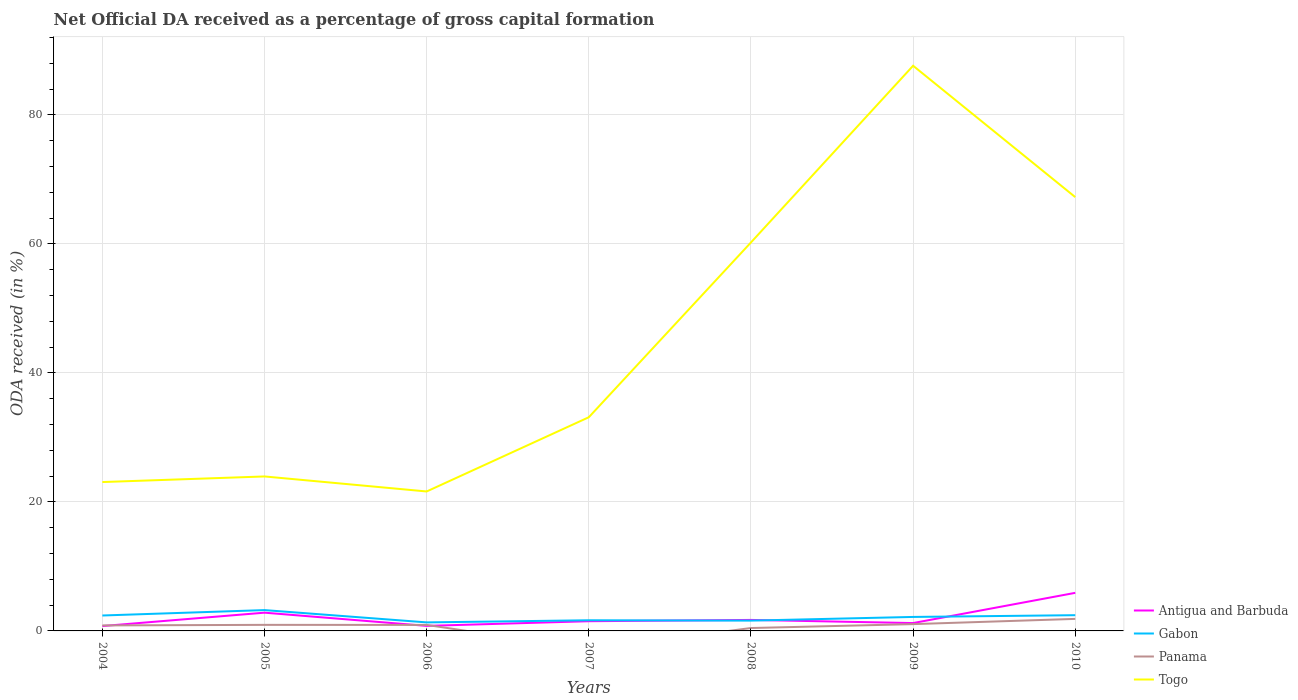Is the number of lines equal to the number of legend labels?
Keep it short and to the point. No. Across all years, what is the maximum net ODA received in Togo?
Provide a succinct answer. 21.62. What is the total net ODA received in Panama in the graph?
Give a very brief answer. -1.01. What is the difference between the highest and the second highest net ODA received in Gabon?
Make the answer very short. 1.91. What is the difference between the highest and the lowest net ODA received in Gabon?
Give a very brief answer. 4. Is the net ODA received in Gabon strictly greater than the net ODA received in Antigua and Barbuda over the years?
Provide a short and direct response. No. How many lines are there?
Make the answer very short. 4. How many years are there in the graph?
Your answer should be compact. 7. Does the graph contain any zero values?
Offer a very short reply. Yes. Does the graph contain grids?
Keep it short and to the point. Yes. Where does the legend appear in the graph?
Your answer should be compact. Bottom right. How are the legend labels stacked?
Offer a terse response. Vertical. What is the title of the graph?
Keep it short and to the point. Net Official DA received as a percentage of gross capital formation. Does "Greece" appear as one of the legend labels in the graph?
Your answer should be compact. No. What is the label or title of the Y-axis?
Your answer should be very brief. ODA received (in %). What is the ODA received (in %) in Antigua and Barbuda in 2004?
Ensure brevity in your answer.  0.75. What is the ODA received (in %) in Gabon in 2004?
Offer a very short reply. 2.39. What is the ODA received (in %) in Panama in 2004?
Provide a short and direct response. 0.85. What is the ODA received (in %) of Togo in 2004?
Your answer should be very brief. 23.08. What is the ODA received (in %) of Antigua and Barbuda in 2005?
Offer a terse response. 2.83. What is the ODA received (in %) of Gabon in 2005?
Provide a short and direct response. 3.23. What is the ODA received (in %) of Panama in 2005?
Keep it short and to the point. 0.94. What is the ODA received (in %) of Togo in 2005?
Give a very brief answer. 23.95. What is the ODA received (in %) of Antigua and Barbuda in 2006?
Keep it short and to the point. 0.78. What is the ODA received (in %) in Gabon in 2006?
Ensure brevity in your answer.  1.32. What is the ODA received (in %) in Panama in 2006?
Provide a short and direct response. 0.93. What is the ODA received (in %) of Togo in 2006?
Provide a short and direct response. 21.62. What is the ODA received (in %) of Antigua and Barbuda in 2007?
Provide a short and direct response. 1.51. What is the ODA received (in %) of Gabon in 2007?
Your response must be concise. 1.65. What is the ODA received (in %) of Togo in 2007?
Offer a very short reply. 33.13. What is the ODA received (in %) in Antigua and Barbuda in 2008?
Ensure brevity in your answer.  1.71. What is the ODA received (in %) of Gabon in 2008?
Give a very brief answer. 1.6. What is the ODA received (in %) in Panama in 2008?
Keep it short and to the point. 0.45. What is the ODA received (in %) of Togo in 2008?
Keep it short and to the point. 60.24. What is the ODA received (in %) in Antigua and Barbuda in 2009?
Provide a short and direct response. 1.22. What is the ODA received (in %) in Gabon in 2009?
Make the answer very short. 2.17. What is the ODA received (in %) in Panama in 2009?
Offer a terse response. 1.05. What is the ODA received (in %) of Togo in 2009?
Your answer should be compact. 87.63. What is the ODA received (in %) of Antigua and Barbuda in 2010?
Make the answer very short. 5.9. What is the ODA received (in %) of Gabon in 2010?
Provide a succinct answer. 2.44. What is the ODA received (in %) of Panama in 2010?
Your answer should be compact. 1.87. What is the ODA received (in %) in Togo in 2010?
Your answer should be compact. 67.27. Across all years, what is the maximum ODA received (in %) of Antigua and Barbuda?
Your response must be concise. 5.9. Across all years, what is the maximum ODA received (in %) of Gabon?
Keep it short and to the point. 3.23. Across all years, what is the maximum ODA received (in %) of Panama?
Your answer should be very brief. 1.87. Across all years, what is the maximum ODA received (in %) in Togo?
Your response must be concise. 87.63. Across all years, what is the minimum ODA received (in %) of Antigua and Barbuda?
Give a very brief answer. 0.75. Across all years, what is the minimum ODA received (in %) in Gabon?
Provide a succinct answer. 1.32. Across all years, what is the minimum ODA received (in %) of Togo?
Offer a very short reply. 21.62. What is the total ODA received (in %) in Antigua and Barbuda in the graph?
Give a very brief answer. 14.7. What is the total ODA received (in %) of Gabon in the graph?
Provide a succinct answer. 14.8. What is the total ODA received (in %) in Panama in the graph?
Ensure brevity in your answer.  6.09. What is the total ODA received (in %) in Togo in the graph?
Provide a short and direct response. 316.93. What is the difference between the ODA received (in %) in Antigua and Barbuda in 2004 and that in 2005?
Ensure brevity in your answer.  -2.08. What is the difference between the ODA received (in %) of Gabon in 2004 and that in 2005?
Your response must be concise. -0.84. What is the difference between the ODA received (in %) in Panama in 2004 and that in 2005?
Keep it short and to the point. -0.09. What is the difference between the ODA received (in %) in Togo in 2004 and that in 2005?
Your response must be concise. -0.87. What is the difference between the ODA received (in %) of Antigua and Barbuda in 2004 and that in 2006?
Your response must be concise. -0.03. What is the difference between the ODA received (in %) in Gabon in 2004 and that in 2006?
Provide a succinct answer. 1.07. What is the difference between the ODA received (in %) of Panama in 2004 and that in 2006?
Make the answer very short. -0.08. What is the difference between the ODA received (in %) in Togo in 2004 and that in 2006?
Give a very brief answer. 1.46. What is the difference between the ODA received (in %) of Antigua and Barbuda in 2004 and that in 2007?
Offer a terse response. -0.75. What is the difference between the ODA received (in %) in Gabon in 2004 and that in 2007?
Give a very brief answer. 0.74. What is the difference between the ODA received (in %) in Togo in 2004 and that in 2007?
Your answer should be compact. -10.05. What is the difference between the ODA received (in %) of Antigua and Barbuda in 2004 and that in 2008?
Offer a very short reply. -0.95. What is the difference between the ODA received (in %) in Gabon in 2004 and that in 2008?
Ensure brevity in your answer.  0.79. What is the difference between the ODA received (in %) in Panama in 2004 and that in 2008?
Your response must be concise. 0.4. What is the difference between the ODA received (in %) of Togo in 2004 and that in 2008?
Provide a succinct answer. -37.15. What is the difference between the ODA received (in %) of Antigua and Barbuda in 2004 and that in 2009?
Your response must be concise. -0.46. What is the difference between the ODA received (in %) of Gabon in 2004 and that in 2009?
Make the answer very short. 0.22. What is the difference between the ODA received (in %) of Panama in 2004 and that in 2009?
Offer a very short reply. -0.2. What is the difference between the ODA received (in %) of Togo in 2004 and that in 2009?
Make the answer very short. -64.55. What is the difference between the ODA received (in %) in Antigua and Barbuda in 2004 and that in 2010?
Your response must be concise. -5.15. What is the difference between the ODA received (in %) of Gabon in 2004 and that in 2010?
Offer a very short reply. -0.05. What is the difference between the ODA received (in %) in Panama in 2004 and that in 2010?
Offer a terse response. -1.01. What is the difference between the ODA received (in %) in Togo in 2004 and that in 2010?
Your response must be concise. -44.18. What is the difference between the ODA received (in %) of Antigua and Barbuda in 2005 and that in 2006?
Provide a succinct answer. 2.05. What is the difference between the ODA received (in %) of Gabon in 2005 and that in 2006?
Your response must be concise. 1.91. What is the difference between the ODA received (in %) in Panama in 2005 and that in 2006?
Provide a succinct answer. 0.01. What is the difference between the ODA received (in %) of Togo in 2005 and that in 2006?
Provide a short and direct response. 2.33. What is the difference between the ODA received (in %) in Antigua and Barbuda in 2005 and that in 2007?
Your answer should be compact. 1.32. What is the difference between the ODA received (in %) of Gabon in 2005 and that in 2007?
Your answer should be compact. 1.58. What is the difference between the ODA received (in %) in Togo in 2005 and that in 2007?
Offer a very short reply. -9.18. What is the difference between the ODA received (in %) of Antigua and Barbuda in 2005 and that in 2008?
Give a very brief answer. 1.12. What is the difference between the ODA received (in %) of Gabon in 2005 and that in 2008?
Keep it short and to the point. 1.63. What is the difference between the ODA received (in %) of Panama in 2005 and that in 2008?
Provide a short and direct response. 0.49. What is the difference between the ODA received (in %) of Togo in 2005 and that in 2008?
Your response must be concise. -36.29. What is the difference between the ODA received (in %) in Antigua and Barbuda in 2005 and that in 2009?
Ensure brevity in your answer.  1.61. What is the difference between the ODA received (in %) of Gabon in 2005 and that in 2009?
Give a very brief answer. 1.06. What is the difference between the ODA received (in %) in Panama in 2005 and that in 2009?
Your answer should be very brief. -0.11. What is the difference between the ODA received (in %) of Togo in 2005 and that in 2009?
Offer a very short reply. -63.68. What is the difference between the ODA received (in %) of Antigua and Barbuda in 2005 and that in 2010?
Provide a succinct answer. -3.07. What is the difference between the ODA received (in %) in Gabon in 2005 and that in 2010?
Make the answer very short. 0.79. What is the difference between the ODA received (in %) of Panama in 2005 and that in 2010?
Provide a succinct answer. -0.93. What is the difference between the ODA received (in %) in Togo in 2005 and that in 2010?
Make the answer very short. -43.31. What is the difference between the ODA received (in %) of Antigua and Barbuda in 2006 and that in 2007?
Your answer should be very brief. -0.72. What is the difference between the ODA received (in %) of Gabon in 2006 and that in 2007?
Ensure brevity in your answer.  -0.33. What is the difference between the ODA received (in %) of Togo in 2006 and that in 2007?
Make the answer very short. -11.51. What is the difference between the ODA received (in %) of Antigua and Barbuda in 2006 and that in 2008?
Offer a very short reply. -0.92. What is the difference between the ODA received (in %) in Gabon in 2006 and that in 2008?
Ensure brevity in your answer.  -0.28. What is the difference between the ODA received (in %) of Panama in 2006 and that in 2008?
Provide a short and direct response. 0.48. What is the difference between the ODA received (in %) in Togo in 2006 and that in 2008?
Give a very brief answer. -38.61. What is the difference between the ODA received (in %) in Antigua and Barbuda in 2006 and that in 2009?
Your answer should be very brief. -0.44. What is the difference between the ODA received (in %) in Gabon in 2006 and that in 2009?
Make the answer very short. -0.85. What is the difference between the ODA received (in %) in Panama in 2006 and that in 2009?
Your answer should be compact. -0.12. What is the difference between the ODA received (in %) of Togo in 2006 and that in 2009?
Make the answer very short. -66.01. What is the difference between the ODA received (in %) of Antigua and Barbuda in 2006 and that in 2010?
Provide a succinct answer. -5.12. What is the difference between the ODA received (in %) in Gabon in 2006 and that in 2010?
Provide a short and direct response. -1.12. What is the difference between the ODA received (in %) of Panama in 2006 and that in 2010?
Offer a terse response. -0.94. What is the difference between the ODA received (in %) in Togo in 2006 and that in 2010?
Provide a short and direct response. -45.64. What is the difference between the ODA received (in %) in Antigua and Barbuda in 2007 and that in 2008?
Your answer should be compact. -0.2. What is the difference between the ODA received (in %) in Gabon in 2007 and that in 2008?
Provide a short and direct response. 0.05. What is the difference between the ODA received (in %) in Togo in 2007 and that in 2008?
Give a very brief answer. -27.11. What is the difference between the ODA received (in %) of Antigua and Barbuda in 2007 and that in 2009?
Your response must be concise. 0.29. What is the difference between the ODA received (in %) in Gabon in 2007 and that in 2009?
Your response must be concise. -0.51. What is the difference between the ODA received (in %) in Togo in 2007 and that in 2009?
Keep it short and to the point. -54.5. What is the difference between the ODA received (in %) in Antigua and Barbuda in 2007 and that in 2010?
Provide a succinct answer. -4.4. What is the difference between the ODA received (in %) of Gabon in 2007 and that in 2010?
Keep it short and to the point. -0.79. What is the difference between the ODA received (in %) in Togo in 2007 and that in 2010?
Keep it short and to the point. -34.13. What is the difference between the ODA received (in %) in Antigua and Barbuda in 2008 and that in 2009?
Provide a short and direct response. 0.49. What is the difference between the ODA received (in %) of Gabon in 2008 and that in 2009?
Keep it short and to the point. -0.57. What is the difference between the ODA received (in %) of Panama in 2008 and that in 2009?
Offer a very short reply. -0.6. What is the difference between the ODA received (in %) of Togo in 2008 and that in 2009?
Give a very brief answer. -27.4. What is the difference between the ODA received (in %) in Antigua and Barbuda in 2008 and that in 2010?
Provide a succinct answer. -4.2. What is the difference between the ODA received (in %) of Gabon in 2008 and that in 2010?
Ensure brevity in your answer.  -0.84. What is the difference between the ODA received (in %) of Panama in 2008 and that in 2010?
Your response must be concise. -1.42. What is the difference between the ODA received (in %) of Togo in 2008 and that in 2010?
Make the answer very short. -7.03. What is the difference between the ODA received (in %) of Antigua and Barbuda in 2009 and that in 2010?
Keep it short and to the point. -4.69. What is the difference between the ODA received (in %) of Gabon in 2009 and that in 2010?
Ensure brevity in your answer.  -0.27. What is the difference between the ODA received (in %) of Panama in 2009 and that in 2010?
Provide a succinct answer. -0.81. What is the difference between the ODA received (in %) of Togo in 2009 and that in 2010?
Provide a short and direct response. 20.37. What is the difference between the ODA received (in %) in Antigua and Barbuda in 2004 and the ODA received (in %) in Gabon in 2005?
Offer a terse response. -2.48. What is the difference between the ODA received (in %) of Antigua and Barbuda in 2004 and the ODA received (in %) of Panama in 2005?
Make the answer very short. -0.19. What is the difference between the ODA received (in %) of Antigua and Barbuda in 2004 and the ODA received (in %) of Togo in 2005?
Make the answer very short. -23.2. What is the difference between the ODA received (in %) in Gabon in 2004 and the ODA received (in %) in Panama in 2005?
Your answer should be very brief. 1.45. What is the difference between the ODA received (in %) in Gabon in 2004 and the ODA received (in %) in Togo in 2005?
Ensure brevity in your answer.  -21.56. What is the difference between the ODA received (in %) of Panama in 2004 and the ODA received (in %) of Togo in 2005?
Make the answer very short. -23.1. What is the difference between the ODA received (in %) in Antigua and Barbuda in 2004 and the ODA received (in %) in Gabon in 2006?
Ensure brevity in your answer.  -0.57. What is the difference between the ODA received (in %) in Antigua and Barbuda in 2004 and the ODA received (in %) in Panama in 2006?
Give a very brief answer. -0.18. What is the difference between the ODA received (in %) of Antigua and Barbuda in 2004 and the ODA received (in %) of Togo in 2006?
Offer a terse response. -20.87. What is the difference between the ODA received (in %) in Gabon in 2004 and the ODA received (in %) in Panama in 2006?
Offer a very short reply. 1.46. What is the difference between the ODA received (in %) in Gabon in 2004 and the ODA received (in %) in Togo in 2006?
Provide a short and direct response. -19.23. What is the difference between the ODA received (in %) of Panama in 2004 and the ODA received (in %) of Togo in 2006?
Your answer should be very brief. -20.77. What is the difference between the ODA received (in %) of Antigua and Barbuda in 2004 and the ODA received (in %) of Gabon in 2007?
Your answer should be compact. -0.9. What is the difference between the ODA received (in %) of Antigua and Barbuda in 2004 and the ODA received (in %) of Togo in 2007?
Your answer should be very brief. -32.38. What is the difference between the ODA received (in %) of Gabon in 2004 and the ODA received (in %) of Togo in 2007?
Provide a short and direct response. -30.74. What is the difference between the ODA received (in %) in Panama in 2004 and the ODA received (in %) in Togo in 2007?
Provide a succinct answer. -32.28. What is the difference between the ODA received (in %) of Antigua and Barbuda in 2004 and the ODA received (in %) of Gabon in 2008?
Ensure brevity in your answer.  -0.84. What is the difference between the ODA received (in %) of Antigua and Barbuda in 2004 and the ODA received (in %) of Panama in 2008?
Provide a short and direct response. 0.3. What is the difference between the ODA received (in %) of Antigua and Barbuda in 2004 and the ODA received (in %) of Togo in 2008?
Offer a terse response. -59.48. What is the difference between the ODA received (in %) of Gabon in 2004 and the ODA received (in %) of Panama in 2008?
Offer a terse response. 1.94. What is the difference between the ODA received (in %) in Gabon in 2004 and the ODA received (in %) in Togo in 2008?
Give a very brief answer. -57.85. What is the difference between the ODA received (in %) in Panama in 2004 and the ODA received (in %) in Togo in 2008?
Your response must be concise. -59.39. What is the difference between the ODA received (in %) in Antigua and Barbuda in 2004 and the ODA received (in %) in Gabon in 2009?
Provide a succinct answer. -1.41. What is the difference between the ODA received (in %) of Antigua and Barbuda in 2004 and the ODA received (in %) of Panama in 2009?
Keep it short and to the point. -0.3. What is the difference between the ODA received (in %) in Antigua and Barbuda in 2004 and the ODA received (in %) in Togo in 2009?
Your response must be concise. -86.88. What is the difference between the ODA received (in %) in Gabon in 2004 and the ODA received (in %) in Panama in 2009?
Provide a short and direct response. 1.34. What is the difference between the ODA received (in %) in Gabon in 2004 and the ODA received (in %) in Togo in 2009?
Your answer should be very brief. -85.24. What is the difference between the ODA received (in %) in Panama in 2004 and the ODA received (in %) in Togo in 2009?
Make the answer very short. -86.78. What is the difference between the ODA received (in %) in Antigua and Barbuda in 2004 and the ODA received (in %) in Gabon in 2010?
Give a very brief answer. -1.68. What is the difference between the ODA received (in %) in Antigua and Barbuda in 2004 and the ODA received (in %) in Panama in 2010?
Provide a succinct answer. -1.11. What is the difference between the ODA received (in %) of Antigua and Barbuda in 2004 and the ODA received (in %) of Togo in 2010?
Your answer should be very brief. -66.51. What is the difference between the ODA received (in %) in Gabon in 2004 and the ODA received (in %) in Panama in 2010?
Your response must be concise. 0.53. What is the difference between the ODA received (in %) in Gabon in 2004 and the ODA received (in %) in Togo in 2010?
Your answer should be compact. -64.87. What is the difference between the ODA received (in %) in Panama in 2004 and the ODA received (in %) in Togo in 2010?
Give a very brief answer. -66.41. What is the difference between the ODA received (in %) in Antigua and Barbuda in 2005 and the ODA received (in %) in Gabon in 2006?
Give a very brief answer. 1.51. What is the difference between the ODA received (in %) of Antigua and Barbuda in 2005 and the ODA received (in %) of Panama in 2006?
Offer a very short reply. 1.9. What is the difference between the ODA received (in %) of Antigua and Barbuda in 2005 and the ODA received (in %) of Togo in 2006?
Give a very brief answer. -18.79. What is the difference between the ODA received (in %) of Gabon in 2005 and the ODA received (in %) of Panama in 2006?
Your response must be concise. 2.3. What is the difference between the ODA received (in %) in Gabon in 2005 and the ODA received (in %) in Togo in 2006?
Provide a short and direct response. -18.39. What is the difference between the ODA received (in %) in Panama in 2005 and the ODA received (in %) in Togo in 2006?
Your answer should be very brief. -20.68. What is the difference between the ODA received (in %) of Antigua and Barbuda in 2005 and the ODA received (in %) of Gabon in 2007?
Provide a short and direct response. 1.18. What is the difference between the ODA received (in %) of Antigua and Barbuda in 2005 and the ODA received (in %) of Togo in 2007?
Your response must be concise. -30.3. What is the difference between the ODA received (in %) of Gabon in 2005 and the ODA received (in %) of Togo in 2007?
Your response must be concise. -29.9. What is the difference between the ODA received (in %) of Panama in 2005 and the ODA received (in %) of Togo in 2007?
Give a very brief answer. -32.19. What is the difference between the ODA received (in %) of Antigua and Barbuda in 2005 and the ODA received (in %) of Gabon in 2008?
Give a very brief answer. 1.23. What is the difference between the ODA received (in %) of Antigua and Barbuda in 2005 and the ODA received (in %) of Panama in 2008?
Offer a very short reply. 2.38. What is the difference between the ODA received (in %) in Antigua and Barbuda in 2005 and the ODA received (in %) in Togo in 2008?
Provide a succinct answer. -57.41. What is the difference between the ODA received (in %) of Gabon in 2005 and the ODA received (in %) of Panama in 2008?
Keep it short and to the point. 2.78. What is the difference between the ODA received (in %) in Gabon in 2005 and the ODA received (in %) in Togo in 2008?
Your answer should be very brief. -57.01. What is the difference between the ODA received (in %) of Panama in 2005 and the ODA received (in %) of Togo in 2008?
Keep it short and to the point. -59.3. What is the difference between the ODA received (in %) in Antigua and Barbuda in 2005 and the ODA received (in %) in Gabon in 2009?
Give a very brief answer. 0.66. What is the difference between the ODA received (in %) of Antigua and Barbuda in 2005 and the ODA received (in %) of Panama in 2009?
Give a very brief answer. 1.78. What is the difference between the ODA received (in %) in Antigua and Barbuda in 2005 and the ODA received (in %) in Togo in 2009?
Your answer should be very brief. -84.8. What is the difference between the ODA received (in %) in Gabon in 2005 and the ODA received (in %) in Panama in 2009?
Give a very brief answer. 2.18. What is the difference between the ODA received (in %) of Gabon in 2005 and the ODA received (in %) of Togo in 2009?
Ensure brevity in your answer.  -84.41. What is the difference between the ODA received (in %) in Panama in 2005 and the ODA received (in %) in Togo in 2009?
Your answer should be very brief. -86.69. What is the difference between the ODA received (in %) of Antigua and Barbuda in 2005 and the ODA received (in %) of Gabon in 2010?
Provide a short and direct response. 0.39. What is the difference between the ODA received (in %) of Antigua and Barbuda in 2005 and the ODA received (in %) of Panama in 2010?
Make the answer very short. 0.96. What is the difference between the ODA received (in %) of Antigua and Barbuda in 2005 and the ODA received (in %) of Togo in 2010?
Give a very brief answer. -64.44. What is the difference between the ODA received (in %) of Gabon in 2005 and the ODA received (in %) of Panama in 2010?
Make the answer very short. 1.36. What is the difference between the ODA received (in %) in Gabon in 2005 and the ODA received (in %) in Togo in 2010?
Your answer should be compact. -64.04. What is the difference between the ODA received (in %) in Panama in 2005 and the ODA received (in %) in Togo in 2010?
Offer a terse response. -66.33. What is the difference between the ODA received (in %) in Antigua and Barbuda in 2006 and the ODA received (in %) in Gabon in 2007?
Give a very brief answer. -0.87. What is the difference between the ODA received (in %) in Antigua and Barbuda in 2006 and the ODA received (in %) in Togo in 2007?
Provide a short and direct response. -32.35. What is the difference between the ODA received (in %) in Gabon in 2006 and the ODA received (in %) in Togo in 2007?
Offer a terse response. -31.81. What is the difference between the ODA received (in %) of Panama in 2006 and the ODA received (in %) of Togo in 2007?
Keep it short and to the point. -32.2. What is the difference between the ODA received (in %) of Antigua and Barbuda in 2006 and the ODA received (in %) of Gabon in 2008?
Make the answer very short. -0.82. What is the difference between the ODA received (in %) in Antigua and Barbuda in 2006 and the ODA received (in %) in Panama in 2008?
Give a very brief answer. 0.33. What is the difference between the ODA received (in %) in Antigua and Barbuda in 2006 and the ODA received (in %) in Togo in 2008?
Your answer should be compact. -59.45. What is the difference between the ODA received (in %) in Gabon in 2006 and the ODA received (in %) in Panama in 2008?
Your response must be concise. 0.87. What is the difference between the ODA received (in %) in Gabon in 2006 and the ODA received (in %) in Togo in 2008?
Your answer should be very brief. -58.92. What is the difference between the ODA received (in %) in Panama in 2006 and the ODA received (in %) in Togo in 2008?
Provide a short and direct response. -59.31. What is the difference between the ODA received (in %) in Antigua and Barbuda in 2006 and the ODA received (in %) in Gabon in 2009?
Keep it short and to the point. -1.38. What is the difference between the ODA received (in %) of Antigua and Barbuda in 2006 and the ODA received (in %) of Panama in 2009?
Offer a very short reply. -0.27. What is the difference between the ODA received (in %) in Antigua and Barbuda in 2006 and the ODA received (in %) in Togo in 2009?
Ensure brevity in your answer.  -86.85. What is the difference between the ODA received (in %) in Gabon in 2006 and the ODA received (in %) in Panama in 2009?
Provide a succinct answer. 0.27. What is the difference between the ODA received (in %) of Gabon in 2006 and the ODA received (in %) of Togo in 2009?
Your answer should be very brief. -86.31. What is the difference between the ODA received (in %) in Panama in 2006 and the ODA received (in %) in Togo in 2009?
Your answer should be very brief. -86.7. What is the difference between the ODA received (in %) of Antigua and Barbuda in 2006 and the ODA received (in %) of Gabon in 2010?
Offer a very short reply. -1.66. What is the difference between the ODA received (in %) of Antigua and Barbuda in 2006 and the ODA received (in %) of Panama in 2010?
Make the answer very short. -1.08. What is the difference between the ODA received (in %) in Antigua and Barbuda in 2006 and the ODA received (in %) in Togo in 2010?
Ensure brevity in your answer.  -66.48. What is the difference between the ODA received (in %) in Gabon in 2006 and the ODA received (in %) in Panama in 2010?
Give a very brief answer. -0.54. What is the difference between the ODA received (in %) of Gabon in 2006 and the ODA received (in %) of Togo in 2010?
Keep it short and to the point. -65.94. What is the difference between the ODA received (in %) in Panama in 2006 and the ODA received (in %) in Togo in 2010?
Your answer should be very brief. -66.34. What is the difference between the ODA received (in %) in Antigua and Barbuda in 2007 and the ODA received (in %) in Gabon in 2008?
Your response must be concise. -0.09. What is the difference between the ODA received (in %) of Antigua and Barbuda in 2007 and the ODA received (in %) of Panama in 2008?
Give a very brief answer. 1.06. What is the difference between the ODA received (in %) of Antigua and Barbuda in 2007 and the ODA received (in %) of Togo in 2008?
Make the answer very short. -58.73. What is the difference between the ODA received (in %) in Gabon in 2007 and the ODA received (in %) in Panama in 2008?
Your answer should be very brief. 1.2. What is the difference between the ODA received (in %) of Gabon in 2007 and the ODA received (in %) of Togo in 2008?
Keep it short and to the point. -58.59. What is the difference between the ODA received (in %) in Antigua and Barbuda in 2007 and the ODA received (in %) in Gabon in 2009?
Your response must be concise. -0.66. What is the difference between the ODA received (in %) of Antigua and Barbuda in 2007 and the ODA received (in %) of Panama in 2009?
Your response must be concise. 0.45. What is the difference between the ODA received (in %) of Antigua and Barbuda in 2007 and the ODA received (in %) of Togo in 2009?
Provide a short and direct response. -86.13. What is the difference between the ODA received (in %) of Gabon in 2007 and the ODA received (in %) of Panama in 2009?
Provide a succinct answer. 0.6. What is the difference between the ODA received (in %) of Gabon in 2007 and the ODA received (in %) of Togo in 2009?
Your answer should be compact. -85.98. What is the difference between the ODA received (in %) in Antigua and Barbuda in 2007 and the ODA received (in %) in Gabon in 2010?
Your answer should be compact. -0.93. What is the difference between the ODA received (in %) in Antigua and Barbuda in 2007 and the ODA received (in %) in Panama in 2010?
Give a very brief answer. -0.36. What is the difference between the ODA received (in %) in Antigua and Barbuda in 2007 and the ODA received (in %) in Togo in 2010?
Make the answer very short. -65.76. What is the difference between the ODA received (in %) of Gabon in 2007 and the ODA received (in %) of Panama in 2010?
Your answer should be compact. -0.21. What is the difference between the ODA received (in %) of Gabon in 2007 and the ODA received (in %) of Togo in 2010?
Your answer should be very brief. -65.61. What is the difference between the ODA received (in %) of Antigua and Barbuda in 2008 and the ODA received (in %) of Gabon in 2009?
Your answer should be compact. -0.46. What is the difference between the ODA received (in %) in Antigua and Barbuda in 2008 and the ODA received (in %) in Panama in 2009?
Ensure brevity in your answer.  0.65. What is the difference between the ODA received (in %) of Antigua and Barbuda in 2008 and the ODA received (in %) of Togo in 2009?
Provide a short and direct response. -85.93. What is the difference between the ODA received (in %) in Gabon in 2008 and the ODA received (in %) in Panama in 2009?
Keep it short and to the point. 0.55. What is the difference between the ODA received (in %) in Gabon in 2008 and the ODA received (in %) in Togo in 2009?
Your answer should be compact. -86.04. What is the difference between the ODA received (in %) in Panama in 2008 and the ODA received (in %) in Togo in 2009?
Provide a succinct answer. -87.19. What is the difference between the ODA received (in %) of Antigua and Barbuda in 2008 and the ODA received (in %) of Gabon in 2010?
Offer a terse response. -0.73. What is the difference between the ODA received (in %) of Antigua and Barbuda in 2008 and the ODA received (in %) of Panama in 2010?
Offer a very short reply. -0.16. What is the difference between the ODA received (in %) in Antigua and Barbuda in 2008 and the ODA received (in %) in Togo in 2010?
Provide a short and direct response. -65.56. What is the difference between the ODA received (in %) of Gabon in 2008 and the ODA received (in %) of Panama in 2010?
Your answer should be very brief. -0.27. What is the difference between the ODA received (in %) in Gabon in 2008 and the ODA received (in %) in Togo in 2010?
Offer a terse response. -65.67. What is the difference between the ODA received (in %) in Panama in 2008 and the ODA received (in %) in Togo in 2010?
Your answer should be compact. -66.82. What is the difference between the ODA received (in %) of Antigua and Barbuda in 2009 and the ODA received (in %) of Gabon in 2010?
Offer a terse response. -1.22. What is the difference between the ODA received (in %) of Antigua and Barbuda in 2009 and the ODA received (in %) of Panama in 2010?
Offer a very short reply. -0.65. What is the difference between the ODA received (in %) in Antigua and Barbuda in 2009 and the ODA received (in %) in Togo in 2010?
Offer a very short reply. -66.05. What is the difference between the ODA received (in %) in Gabon in 2009 and the ODA received (in %) in Panama in 2010?
Keep it short and to the point. 0.3. What is the difference between the ODA received (in %) in Gabon in 2009 and the ODA received (in %) in Togo in 2010?
Your answer should be very brief. -65.1. What is the difference between the ODA received (in %) of Panama in 2009 and the ODA received (in %) of Togo in 2010?
Provide a succinct answer. -66.21. What is the average ODA received (in %) of Antigua and Barbuda per year?
Offer a very short reply. 2.1. What is the average ODA received (in %) of Gabon per year?
Your answer should be compact. 2.11. What is the average ODA received (in %) of Panama per year?
Your answer should be very brief. 0.87. What is the average ODA received (in %) of Togo per year?
Keep it short and to the point. 45.28. In the year 2004, what is the difference between the ODA received (in %) of Antigua and Barbuda and ODA received (in %) of Gabon?
Ensure brevity in your answer.  -1.64. In the year 2004, what is the difference between the ODA received (in %) in Antigua and Barbuda and ODA received (in %) in Panama?
Your answer should be compact. -0.1. In the year 2004, what is the difference between the ODA received (in %) of Antigua and Barbuda and ODA received (in %) of Togo?
Give a very brief answer. -22.33. In the year 2004, what is the difference between the ODA received (in %) of Gabon and ODA received (in %) of Panama?
Your answer should be compact. 1.54. In the year 2004, what is the difference between the ODA received (in %) in Gabon and ODA received (in %) in Togo?
Offer a very short reply. -20.69. In the year 2004, what is the difference between the ODA received (in %) in Panama and ODA received (in %) in Togo?
Offer a very short reply. -22.23. In the year 2005, what is the difference between the ODA received (in %) in Antigua and Barbuda and ODA received (in %) in Gabon?
Keep it short and to the point. -0.4. In the year 2005, what is the difference between the ODA received (in %) in Antigua and Barbuda and ODA received (in %) in Panama?
Offer a very short reply. 1.89. In the year 2005, what is the difference between the ODA received (in %) in Antigua and Barbuda and ODA received (in %) in Togo?
Ensure brevity in your answer.  -21.12. In the year 2005, what is the difference between the ODA received (in %) in Gabon and ODA received (in %) in Panama?
Provide a short and direct response. 2.29. In the year 2005, what is the difference between the ODA received (in %) in Gabon and ODA received (in %) in Togo?
Offer a very short reply. -20.72. In the year 2005, what is the difference between the ODA received (in %) of Panama and ODA received (in %) of Togo?
Offer a terse response. -23.01. In the year 2006, what is the difference between the ODA received (in %) in Antigua and Barbuda and ODA received (in %) in Gabon?
Make the answer very short. -0.54. In the year 2006, what is the difference between the ODA received (in %) in Antigua and Barbuda and ODA received (in %) in Panama?
Provide a succinct answer. -0.15. In the year 2006, what is the difference between the ODA received (in %) of Antigua and Barbuda and ODA received (in %) of Togo?
Make the answer very short. -20.84. In the year 2006, what is the difference between the ODA received (in %) in Gabon and ODA received (in %) in Panama?
Provide a short and direct response. 0.39. In the year 2006, what is the difference between the ODA received (in %) in Gabon and ODA received (in %) in Togo?
Make the answer very short. -20.3. In the year 2006, what is the difference between the ODA received (in %) of Panama and ODA received (in %) of Togo?
Provide a succinct answer. -20.69. In the year 2007, what is the difference between the ODA received (in %) in Antigua and Barbuda and ODA received (in %) in Gabon?
Ensure brevity in your answer.  -0.15. In the year 2007, what is the difference between the ODA received (in %) in Antigua and Barbuda and ODA received (in %) in Togo?
Provide a succinct answer. -31.63. In the year 2007, what is the difference between the ODA received (in %) of Gabon and ODA received (in %) of Togo?
Ensure brevity in your answer.  -31.48. In the year 2008, what is the difference between the ODA received (in %) of Antigua and Barbuda and ODA received (in %) of Gabon?
Ensure brevity in your answer.  0.11. In the year 2008, what is the difference between the ODA received (in %) of Antigua and Barbuda and ODA received (in %) of Panama?
Give a very brief answer. 1.26. In the year 2008, what is the difference between the ODA received (in %) of Antigua and Barbuda and ODA received (in %) of Togo?
Your response must be concise. -58.53. In the year 2008, what is the difference between the ODA received (in %) of Gabon and ODA received (in %) of Panama?
Offer a terse response. 1.15. In the year 2008, what is the difference between the ODA received (in %) of Gabon and ODA received (in %) of Togo?
Give a very brief answer. -58.64. In the year 2008, what is the difference between the ODA received (in %) in Panama and ODA received (in %) in Togo?
Provide a short and direct response. -59.79. In the year 2009, what is the difference between the ODA received (in %) of Antigua and Barbuda and ODA received (in %) of Gabon?
Keep it short and to the point. -0.95. In the year 2009, what is the difference between the ODA received (in %) of Antigua and Barbuda and ODA received (in %) of Panama?
Your answer should be compact. 0.17. In the year 2009, what is the difference between the ODA received (in %) of Antigua and Barbuda and ODA received (in %) of Togo?
Ensure brevity in your answer.  -86.42. In the year 2009, what is the difference between the ODA received (in %) in Gabon and ODA received (in %) in Panama?
Make the answer very short. 1.11. In the year 2009, what is the difference between the ODA received (in %) in Gabon and ODA received (in %) in Togo?
Offer a terse response. -85.47. In the year 2009, what is the difference between the ODA received (in %) in Panama and ODA received (in %) in Togo?
Your response must be concise. -86.58. In the year 2010, what is the difference between the ODA received (in %) of Antigua and Barbuda and ODA received (in %) of Gabon?
Ensure brevity in your answer.  3.47. In the year 2010, what is the difference between the ODA received (in %) in Antigua and Barbuda and ODA received (in %) in Panama?
Provide a succinct answer. 4.04. In the year 2010, what is the difference between the ODA received (in %) in Antigua and Barbuda and ODA received (in %) in Togo?
Make the answer very short. -61.36. In the year 2010, what is the difference between the ODA received (in %) of Gabon and ODA received (in %) of Panama?
Your answer should be compact. 0.57. In the year 2010, what is the difference between the ODA received (in %) in Gabon and ODA received (in %) in Togo?
Ensure brevity in your answer.  -64.83. In the year 2010, what is the difference between the ODA received (in %) in Panama and ODA received (in %) in Togo?
Offer a very short reply. -65.4. What is the ratio of the ODA received (in %) of Antigua and Barbuda in 2004 to that in 2005?
Provide a succinct answer. 0.27. What is the ratio of the ODA received (in %) in Gabon in 2004 to that in 2005?
Offer a terse response. 0.74. What is the ratio of the ODA received (in %) in Panama in 2004 to that in 2005?
Make the answer very short. 0.91. What is the ratio of the ODA received (in %) in Togo in 2004 to that in 2005?
Keep it short and to the point. 0.96. What is the ratio of the ODA received (in %) in Antigua and Barbuda in 2004 to that in 2006?
Give a very brief answer. 0.96. What is the ratio of the ODA received (in %) in Gabon in 2004 to that in 2006?
Your answer should be very brief. 1.81. What is the ratio of the ODA received (in %) of Panama in 2004 to that in 2006?
Your answer should be very brief. 0.92. What is the ratio of the ODA received (in %) in Togo in 2004 to that in 2006?
Your answer should be very brief. 1.07. What is the ratio of the ODA received (in %) in Antigua and Barbuda in 2004 to that in 2007?
Provide a succinct answer. 0.5. What is the ratio of the ODA received (in %) of Gabon in 2004 to that in 2007?
Ensure brevity in your answer.  1.45. What is the ratio of the ODA received (in %) of Togo in 2004 to that in 2007?
Offer a terse response. 0.7. What is the ratio of the ODA received (in %) in Antigua and Barbuda in 2004 to that in 2008?
Provide a succinct answer. 0.44. What is the ratio of the ODA received (in %) in Gabon in 2004 to that in 2008?
Your answer should be compact. 1.5. What is the ratio of the ODA received (in %) in Panama in 2004 to that in 2008?
Keep it short and to the point. 1.9. What is the ratio of the ODA received (in %) in Togo in 2004 to that in 2008?
Offer a very short reply. 0.38. What is the ratio of the ODA received (in %) of Antigua and Barbuda in 2004 to that in 2009?
Ensure brevity in your answer.  0.62. What is the ratio of the ODA received (in %) of Gabon in 2004 to that in 2009?
Your answer should be compact. 1.1. What is the ratio of the ODA received (in %) of Panama in 2004 to that in 2009?
Offer a terse response. 0.81. What is the ratio of the ODA received (in %) of Togo in 2004 to that in 2009?
Provide a short and direct response. 0.26. What is the ratio of the ODA received (in %) in Antigua and Barbuda in 2004 to that in 2010?
Ensure brevity in your answer.  0.13. What is the ratio of the ODA received (in %) in Gabon in 2004 to that in 2010?
Keep it short and to the point. 0.98. What is the ratio of the ODA received (in %) in Panama in 2004 to that in 2010?
Make the answer very short. 0.46. What is the ratio of the ODA received (in %) in Togo in 2004 to that in 2010?
Offer a very short reply. 0.34. What is the ratio of the ODA received (in %) of Antigua and Barbuda in 2005 to that in 2006?
Make the answer very short. 3.61. What is the ratio of the ODA received (in %) in Gabon in 2005 to that in 2006?
Offer a very short reply. 2.44. What is the ratio of the ODA received (in %) in Togo in 2005 to that in 2006?
Your answer should be very brief. 1.11. What is the ratio of the ODA received (in %) in Antigua and Barbuda in 2005 to that in 2007?
Offer a terse response. 1.88. What is the ratio of the ODA received (in %) of Gabon in 2005 to that in 2007?
Provide a succinct answer. 1.95. What is the ratio of the ODA received (in %) in Togo in 2005 to that in 2007?
Your answer should be compact. 0.72. What is the ratio of the ODA received (in %) in Antigua and Barbuda in 2005 to that in 2008?
Provide a succinct answer. 1.66. What is the ratio of the ODA received (in %) in Gabon in 2005 to that in 2008?
Your response must be concise. 2.02. What is the ratio of the ODA received (in %) of Panama in 2005 to that in 2008?
Offer a terse response. 2.09. What is the ratio of the ODA received (in %) of Togo in 2005 to that in 2008?
Keep it short and to the point. 0.4. What is the ratio of the ODA received (in %) in Antigua and Barbuda in 2005 to that in 2009?
Ensure brevity in your answer.  2.32. What is the ratio of the ODA received (in %) in Gabon in 2005 to that in 2009?
Make the answer very short. 1.49. What is the ratio of the ODA received (in %) in Panama in 2005 to that in 2009?
Keep it short and to the point. 0.89. What is the ratio of the ODA received (in %) of Togo in 2005 to that in 2009?
Offer a terse response. 0.27. What is the ratio of the ODA received (in %) of Antigua and Barbuda in 2005 to that in 2010?
Offer a very short reply. 0.48. What is the ratio of the ODA received (in %) of Gabon in 2005 to that in 2010?
Keep it short and to the point. 1.32. What is the ratio of the ODA received (in %) of Panama in 2005 to that in 2010?
Provide a succinct answer. 0.5. What is the ratio of the ODA received (in %) in Togo in 2005 to that in 2010?
Make the answer very short. 0.36. What is the ratio of the ODA received (in %) of Antigua and Barbuda in 2006 to that in 2007?
Give a very brief answer. 0.52. What is the ratio of the ODA received (in %) in Gabon in 2006 to that in 2007?
Offer a very short reply. 0.8. What is the ratio of the ODA received (in %) of Togo in 2006 to that in 2007?
Provide a short and direct response. 0.65. What is the ratio of the ODA received (in %) in Antigua and Barbuda in 2006 to that in 2008?
Provide a short and direct response. 0.46. What is the ratio of the ODA received (in %) in Gabon in 2006 to that in 2008?
Offer a terse response. 0.83. What is the ratio of the ODA received (in %) in Panama in 2006 to that in 2008?
Offer a terse response. 2.07. What is the ratio of the ODA received (in %) of Togo in 2006 to that in 2008?
Your answer should be compact. 0.36. What is the ratio of the ODA received (in %) in Antigua and Barbuda in 2006 to that in 2009?
Your answer should be compact. 0.64. What is the ratio of the ODA received (in %) in Gabon in 2006 to that in 2009?
Offer a terse response. 0.61. What is the ratio of the ODA received (in %) of Panama in 2006 to that in 2009?
Your answer should be compact. 0.88. What is the ratio of the ODA received (in %) of Togo in 2006 to that in 2009?
Your response must be concise. 0.25. What is the ratio of the ODA received (in %) in Antigua and Barbuda in 2006 to that in 2010?
Your answer should be compact. 0.13. What is the ratio of the ODA received (in %) in Gabon in 2006 to that in 2010?
Make the answer very short. 0.54. What is the ratio of the ODA received (in %) in Panama in 2006 to that in 2010?
Give a very brief answer. 0.5. What is the ratio of the ODA received (in %) in Togo in 2006 to that in 2010?
Ensure brevity in your answer.  0.32. What is the ratio of the ODA received (in %) of Antigua and Barbuda in 2007 to that in 2008?
Provide a succinct answer. 0.88. What is the ratio of the ODA received (in %) in Gabon in 2007 to that in 2008?
Your response must be concise. 1.03. What is the ratio of the ODA received (in %) of Togo in 2007 to that in 2008?
Keep it short and to the point. 0.55. What is the ratio of the ODA received (in %) in Antigua and Barbuda in 2007 to that in 2009?
Provide a succinct answer. 1.24. What is the ratio of the ODA received (in %) of Gabon in 2007 to that in 2009?
Provide a succinct answer. 0.76. What is the ratio of the ODA received (in %) of Togo in 2007 to that in 2009?
Provide a succinct answer. 0.38. What is the ratio of the ODA received (in %) in Antigua and Barbuda in 2007 to that in 2010?
Give a very brief answer. 0.26. What is the ratio of the ODA received (in %) in Gabon in 2007 to that in 2010?
Your answer should be very brief. 0.68. What is the ratio of the ODA received (in %) in Togo in 2007 to that in 2010?
Your answer should be compact. 0.49. What is the ratio of the ODA received (in %) in Antigua and Barbuda in 2008 to that in 2009?
Your answer should be compact. 1.4. What is the ratio of the ODA received (in %) of Gabon in 2008 to that in 2009?
Give a very brief answer. 0.74. What is the ratio of the ODA received (in %) in Panama in 2008 to that in 2009?
Offer a very short reply. 0.43. What is the ratio of the ODA received (in %) of Togo in 2008 to that in 2009?
Offer a terse response. 0.69. What is the ratio of the ODA received (in %) of Antigua and Barbuda in 2008 to that in 2010?
Provide a short and direct response. 0.29. What is the ratio of the ODA received (in %) of Gabon in 2008 to that in 2010?
Offer a terse response. 0.66. What is the ratio of the ODA received (in %) of Panama in 2008 to that in 2010?
Give a very brief answer. 0.24. What is the ratio of the ODA received (in %) of Togo in 2008 to that in 2010?
Provide a short and direct response. 0.9. What is the ratio of the ODA received (in %) in Antigua and Barbuda in 2009 to that in 2010?
Offer a terse response. 0.21. What is the ratio of the ODA received (in %) of Gabon in 2009 to that in 2010?
Your response must be concise. 0.89. What is the ratio of the ODA received (in %) in Panama in 2009 to that in 2010?
Keep it short and to the point. 0.56. What is the ratio of the ODA received (in %) of Togo in 2009 to that in 2010?
Your answer should be very brief. 1.3. What is the difference between the highest and the second highest ODA received (in %) of Antigua and Barbuda?
Keep it short and to the point. 3.07. What is the difference between the highest and the second highest ODA received (in %) in Gabon?
Ensure brevity in your answer.  0.79. What is the difference between the highest and the second highest ODA received (in %) of Panama?
Ensure brevity in your answer.  0.81. What is the difference between the highest and the second highest ODA received (in %) in Togo?
Make the answer very short. 20.37. What is the difference between the highest and the lowest ODA received (in %) of Antigua and Barbuda?
Provide a succinct answer. 5.15. What is the difference between the highest and the lowest ODA received (in %) of Gabon?
Give a very brief answer. 1.91. What is the difference between the highest and the lowest ODA received (in %) in Panama?
Give a very brief answer. 1.87. What is the difference between the highest and the lowest ODA received (in %) in Togo?
Keep it short and to the point. 66.01. 